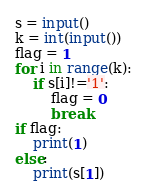Convert code to text. <code><loc_0><loc_0><loc_500><loc_500><_Python_>s = input()
k = int(input())
flag = 1
for i in range(k):
    if s[i]!='1':
        flag = 0
        break
if flag:
    print(1)
else:
    print(s[1])
</code> 